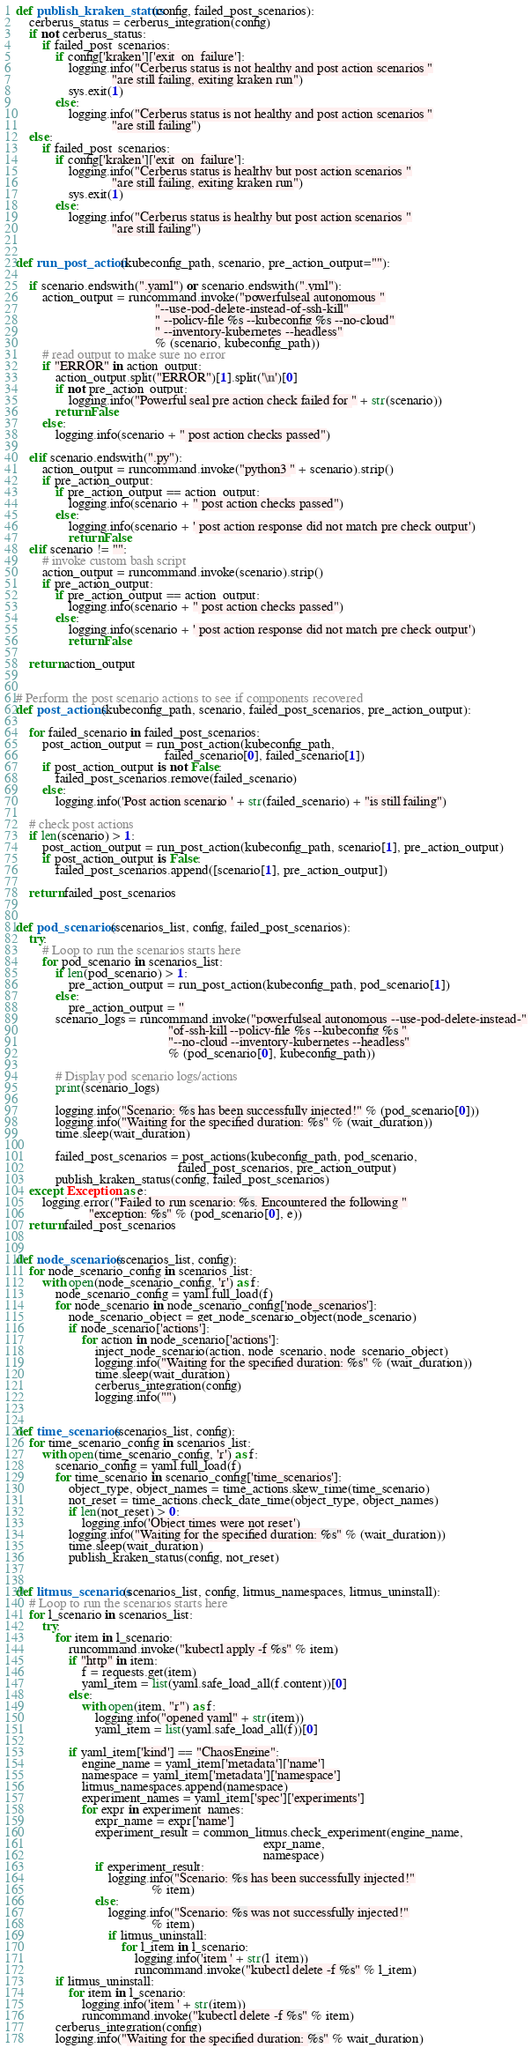Convert code to text. <code><loc_0><loc_0><loc_500><loc_500><_Python_>def publish_kraken_status(config, failed_post_scenarios):
    cerberus_status = cerberus_integration(config)
    if not cerberus_status:
        if failed_post_scenarios:
            if config['kraken']['exit_on_failure']:
                logging.info("Cerberus status is not healthy and post action scenarios "
                             "are still failing, exiting kraken run")
                sys.exit(1)
            else:
                logging.info("Cerberus status is not healthy and post action scenarios "
                             "are still failing")
    else:
        if failed_post_scenarios:
            if config['kraken']['exit_on_failure']:
                logging.info("Cerberus status is healthy but post action scenarios "
                             "are still failing, exiting kraken run")
                sys.exit(1)
            else:
                logging.info("Cerberus status is healthy but post action scenarios "
                             "are still failing")


def run_post_action(kubeconfig_path, scenario, pre_action_output=""):

    if scenario.endswith(".yaml") or scenario.endswith(".yml"):
        action_output = runcommand.invoke("powerfulseal autonomous "
                                          "--use-pod-delete-instead-of-ssh-kill"
                                          " --policy-file %s --kubeconfig %s --no-cloud"
                                          " --inventory-kubernetes --headless"
                                          % (scenario, kubeconfig_path))
        # read output to make sure no error
        if "ERROR" in action_output:
            action_output.split("ERROR")[1].split('\n')[0]
            if not pre_action_output:
                logging.info("Powerful seal pre action check failed for " + str(scenario))
            return False
        else:
            logging.info(scenario + " post action checks passed")

    elif scenario.endswith(".py"):
        action_output = runcommand.invoke("python3 " + scenario).strip()
        if pre_action_output:
            if pre_action_output == action_output:
                logging.info(scenario + " post action checks passed")
            else:
                logging.info(scenario + ' post action response did not match pre check output')
                return False
    elif scenario != "":
        # invoke custom bash script
        action_output = runcommand.invoke(scenario).strip()
        if pre_action_output:
            if pre_action_output == action_output:
                logging.info(scenario + " post action checks passed")
            else:
                logging.info(scenario + ' post action response did not match pre check output')
                return False

    return action_output


# Perform the post scenario actions to see if components recovered
def post_actions(kubeconfig_path, scenario, failed_post_scenarios, pre_action_output):

    for failed_scenario in failed_post_scenarios:
        post_action_output = run_post_action(kubeconfig_path,
                                             failed_scenario[0], failed_scenario[1])
        if post_action_output is not False:
            failed_post_scenarios.remove(failed_scenario)
        else:
            logging.info('Post action scenario ' + str(failed_scenario) + "is still failing")

    # check post actions
    if len(scenario) > 1:
        post_action_output = run_post_action(kubeconfig_path, scenario[1], pre_action_output)
        if post_action_output is False:
            failed_post_scenarios.append([scenario[1], pre_action_output])

    return failed_post_scenarios


def pod_scenarios(scenarios_list, config, failed_post_scenarios):
    try:
        # Loop to run the scenarios starts here
        for pod_scenario in scenarios_list:
            if len(pod_scenario) > 1:
                pre_action_output = run_post_action(kubeconfig_path, pod_scenario[1])
            else:
                pre_action_output = ''
            scenario_logs = runcommand.invoke("powerfulseal autonomous --use-pod-delete-instead-"
                                              "of-ssh-kill --policy-file %s --kubeconfig %s "
                                              "--no-cloud --inventory-kubernetes --headless"
                                              % (pod_scenario[0], kubeconfig_path))

            # Display pod scenario logs/actions
            print(scenario_logs)

            logging.info("Scenario: %s has been successfully injected!" % (pod_scenario[0]))
            logging.info("Waiting for the specified duration: %s" % (wait_duration))
            time.sleep(wait_duration)

            failed_post_scenarios = post_actions(kubeconfig_path, pod_scenario,
                                                 failed_post_scenarios, pre_action_output)
            publish_kraken_status(config, failed_post_scenarios)
    except Exception as e:
        logging.error("Failed to run scenario: %s. Encountered the following "
                      "exception: %s" % (pod_scenario[0], e))
    return failed_post_scenarios


def node_scenarios(scenarios_list, config):
    for node_scenario_config in scenarios_list:
        with open(node_scenario_config, 'r') as f:
            node_scenario_config = yaml.full_load(f)
            for node_scenario in node_scenario_config['node_scenarios']:
                node_scenario_object = get_node_scenario_object(node_scenario)
                if node_scenario['actions']:
                    for action in node_scenario['actions']:
                        inject_node_scenario(action, node_scenario, node_scenario_object)
                        logging.info("Waiting for the specified duration: %s" % (wait_duration))
                        time.sleep(wait_duration)
                        cerberus_integration(config)
                        logging.info("")


def time_scenarios(scenarios_list, config):
    for time_scenario_config in scenarios_list:
        with open(time_scenario_config, 'r') as f:
            scenario_config = yaml.full_load(f)
            for time_scenario in scenario_config['time_scenarios']:
                object_type, object_names = time_actions.skew_time(time_scenario)
                not_reset = time_actions.check_date_time(object_type, object_names)
                if len(not_reset) > 0:
                    logging.info('Object times were not reset')
                logging.info("Waiting for the specified duration: %s" % (wait_duration))
                time.sleep(wait_duration)
                publish_kraken_status(config, not_reset)


def litmus_scenarios(scenarios_list, config, litmus_namespaces, litmus_uninstall):
    # Loop to run the scenarios starts here
    for l_scenario in scenarios_list:
        try:
            for item in l_scenario:
                runcommand.invoke("kubectl apply -f %s" % item)
                if "http" in item:
                    f = requests.get(item)
                    yaml_item = list(yaml.safe_load_all(f.content))[0]
                else:
                    with open(item, "r") as f:
                        logging.info("opened yaml" + str(item))
                        yaml_item = list(yaml.safe_load_all(f))[0]

                if yaml_item['kind'] == "ChaosEngine":
                    engine_name = yaml_item['metadata']['name']
                    namespace = yaml_item['metadata']['namespace']
                    litmus_namespaces.append(namespace)
                    experiment_names = yaml_item['spec']['experiments']
                    for expr in experiment_names:
                        expr_name = expr['name']
                        experiment_result = common_litmus.check_experiment(engine_name,
                                                                           expr_name,
                                                                           namespace)
                        if experiment_result:
                            logging.info("Scenario: %s has been successfully injected!"
                                         % item)
                        else:
                            logging.info("Scenario: %s was not successfully injected!"
                                         % item)
                            if litmus_uninstall:
                                for l_item in l_scenario:
                                    logging.info('item ' + str(l_item))
                                    runcommand.invoke("kubectl delete -f %s" % l_item)
            if litmus_uninstall:
                for item in l_scenario:
                    logging.info('item ' + str(item))
                    runcommand.invoke("kubectl delete -f %s" % item)
            cerberus_integration(config)
            logging.info("Waiting for the specified duration: %s" % wait_duration)</code> 